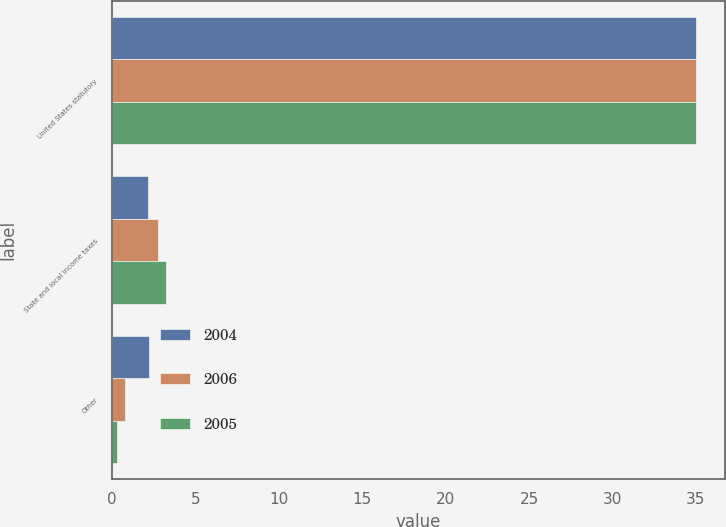Convert chart to OTSL. <chart><loc_0><loc_0><loc_500><loc_500><stacked_bar_chart><ecel><fcel>United States statutory<fcel>State and local income taxes<fcel>Other<nl><fcel>2004<fcel>35<fcel>2.17<fcel>2.18<nl><fcel>2006<fcel>35<fcel>2.74<fcel>0.77<nl><fcel>2005<fcel>35<fcel>3.21<fcel>0.29<nl></chart> 